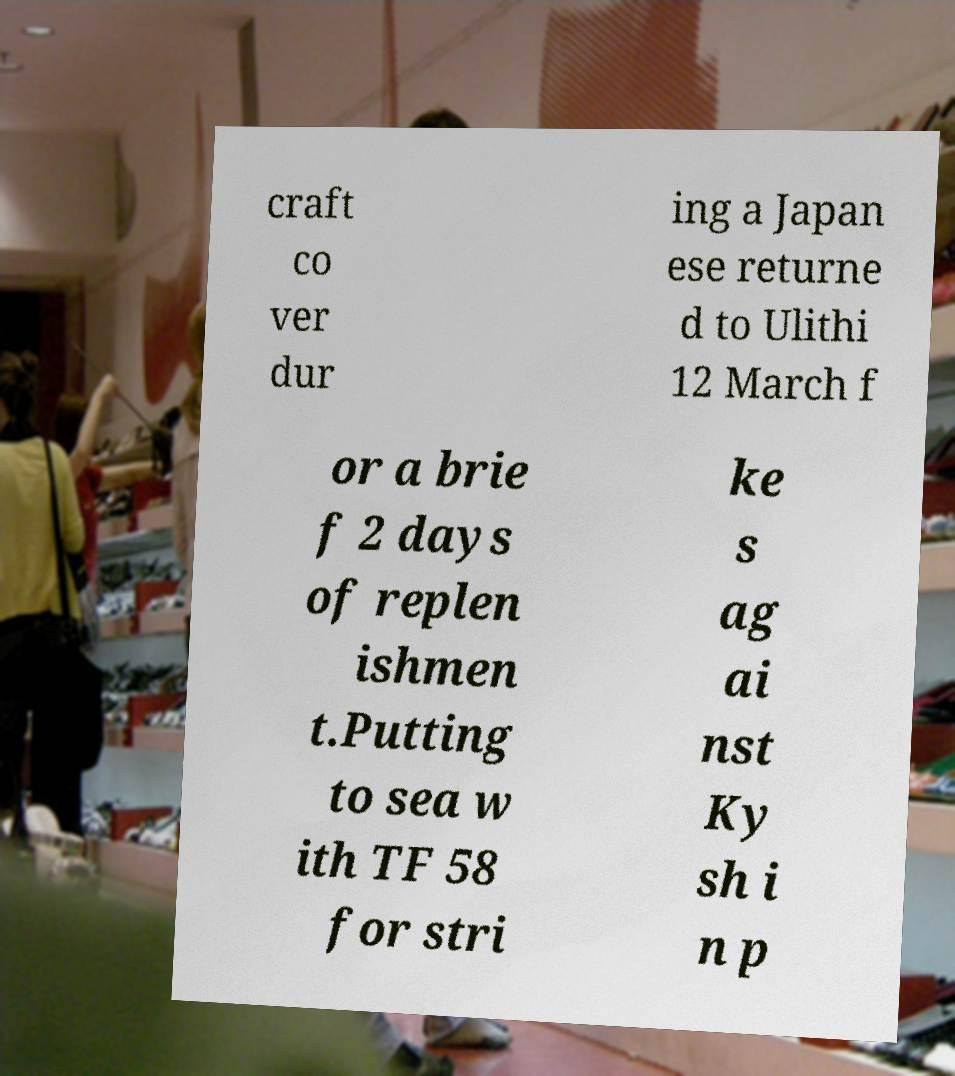Please identify and transcribe the text found in this image. craft co ver dur ing a Japan ese returne d to Ulithi 12 March f or a brie f 2 days of replen ishmen t.Putting to sea w ith TF 58 for stri ke s ag ai nst Ky sh i n p 